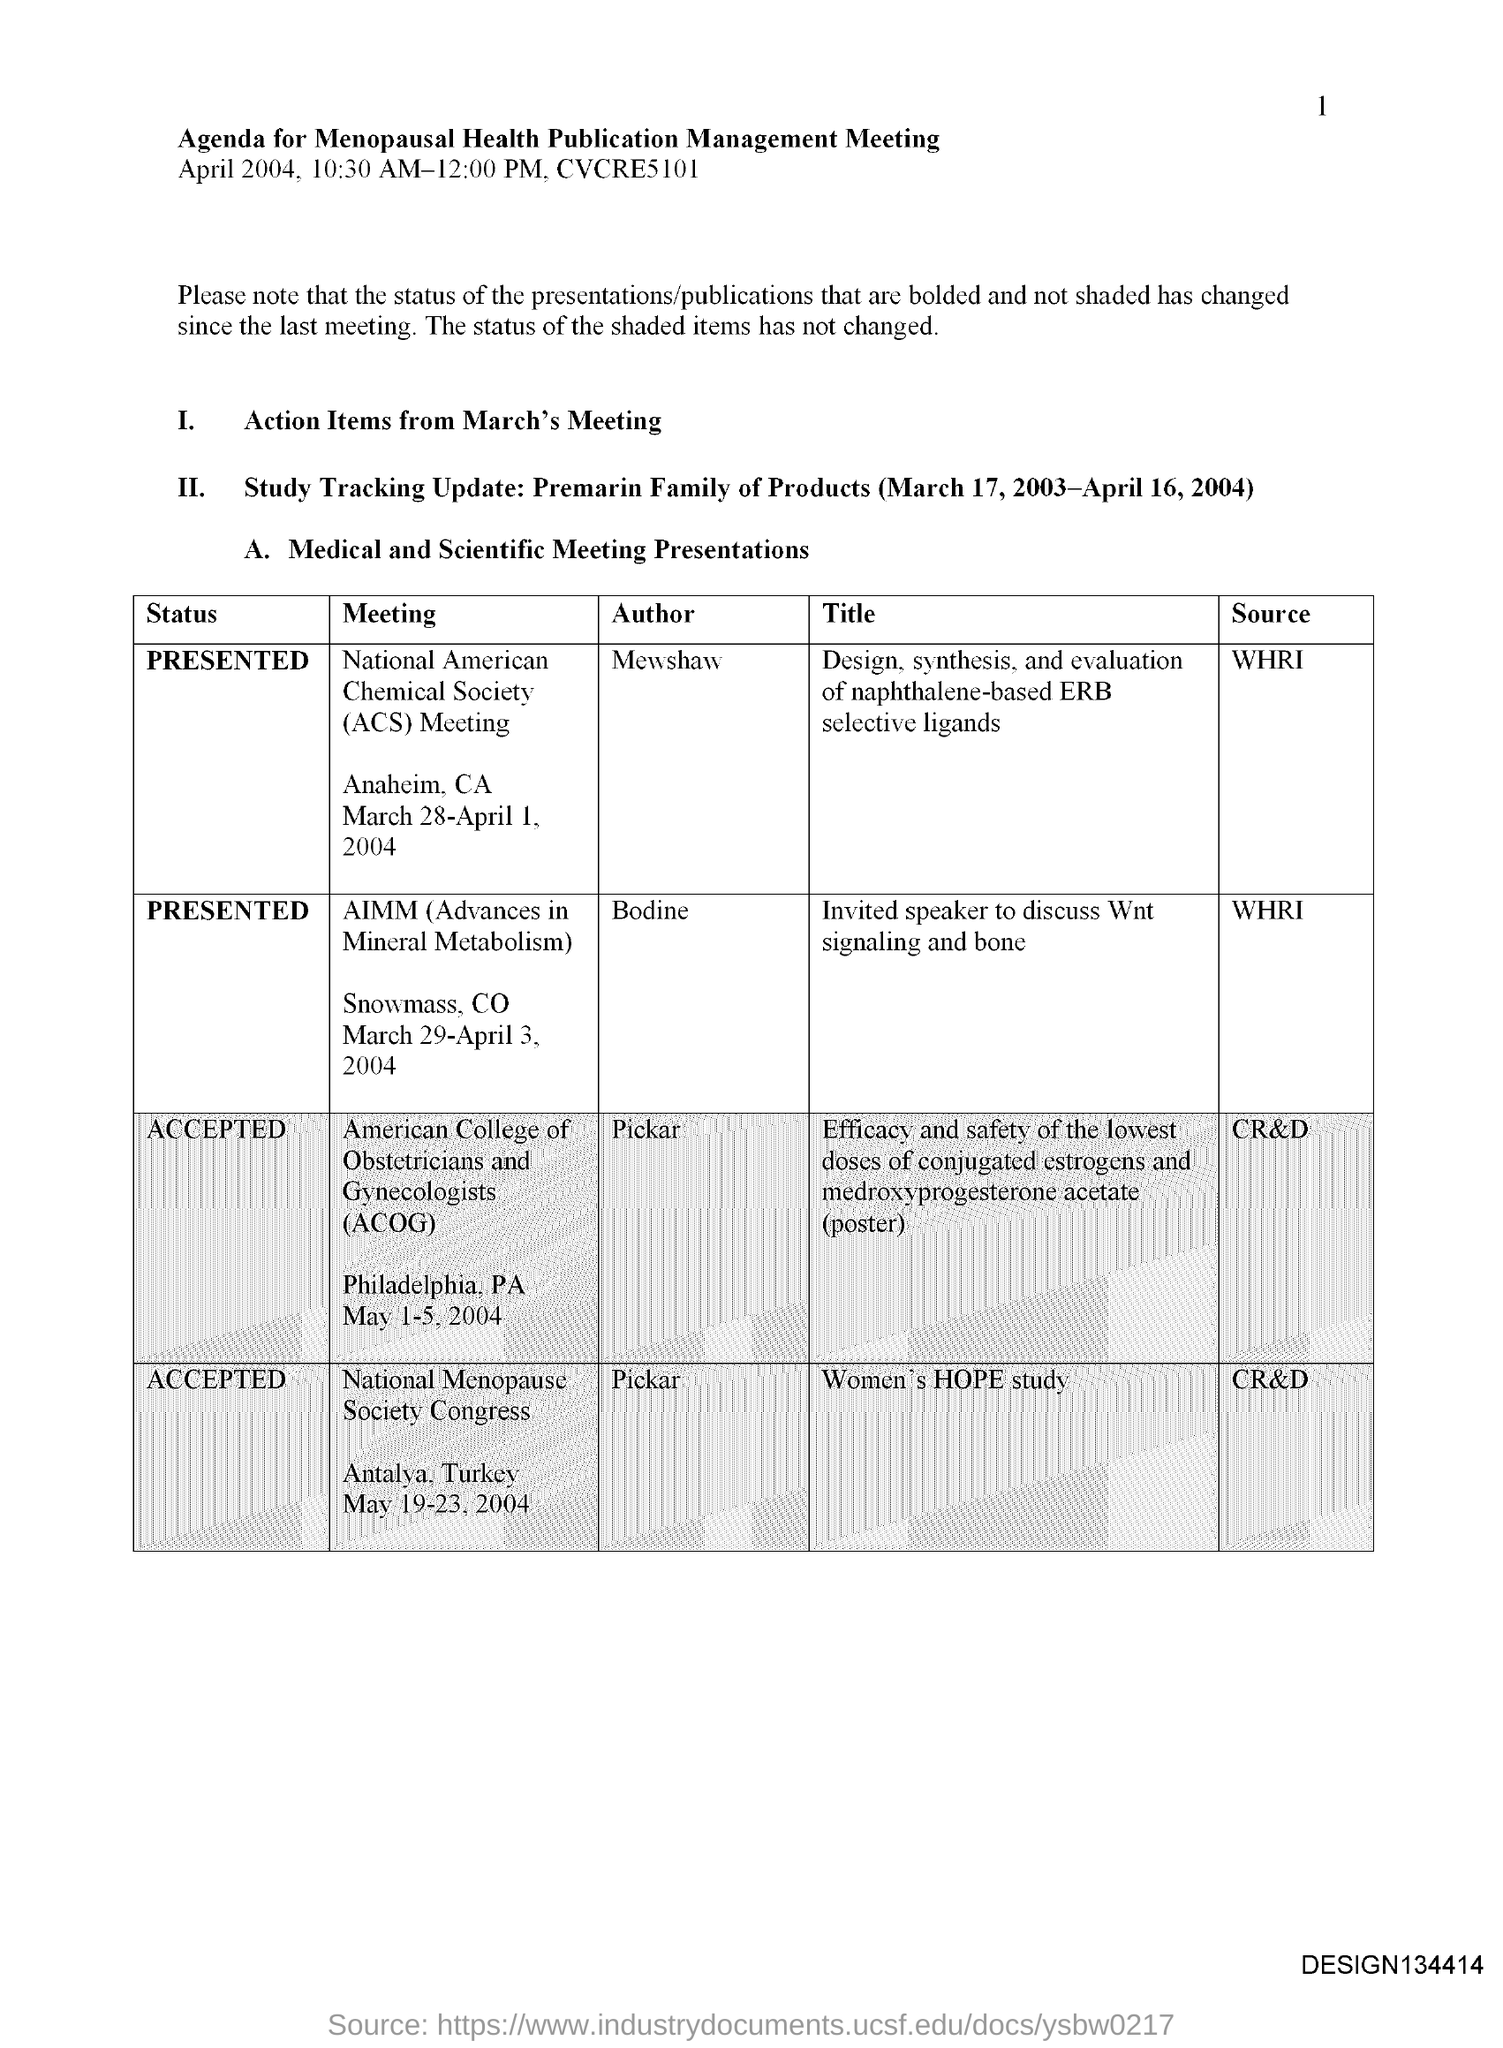What is the page number?
Make the answer very short. 1. What is the title of the document?
Provide a short and direct response. Agenda for Menopausal health publication management meeting. What is the full form of AIMM?
Your answer should be very brief. Advances in mineral Metabolism. Who is the author of the meeting "National Menopause Society Congress"?
Provide a succinct answer. Pickar. What is the status of the meeting ACOG?
Your answer should be very brief. ACCEPTED. 